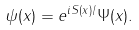Convert formula to latex. <formula><loc_0><loc_0><loc_500><loc_500>\psi ( x ) = e ^ { i S ( x ) / } \Psi ( x ) .</formula> 